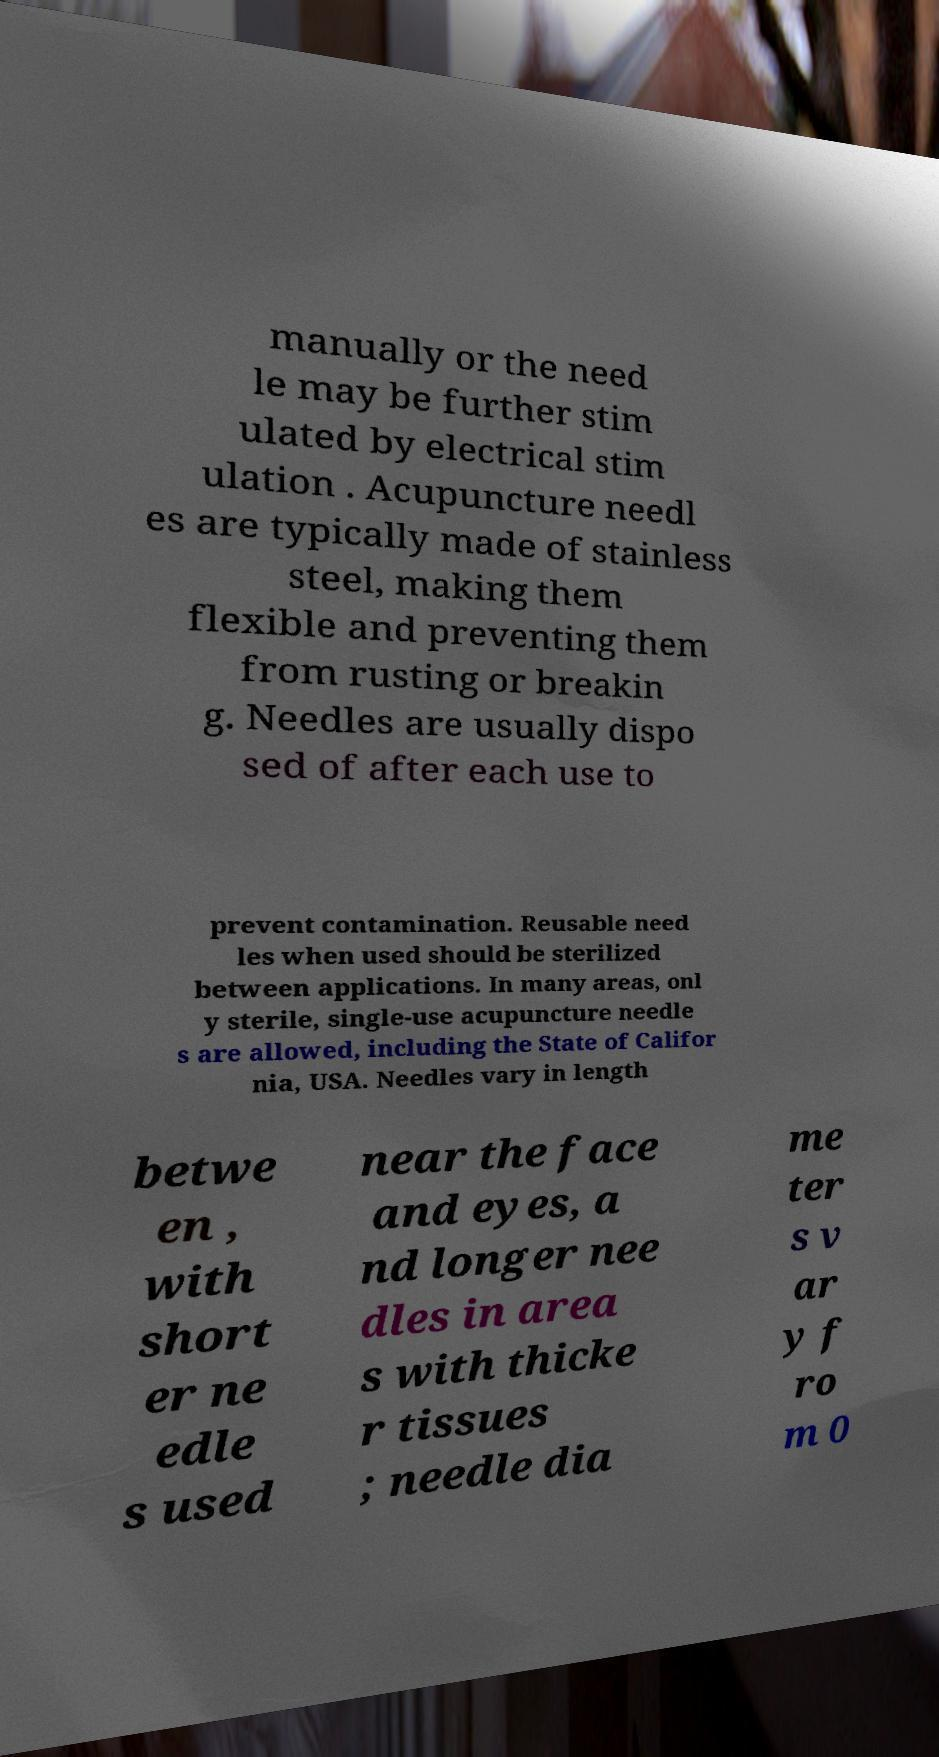I need the written content from this picture converted into text. Can you do that? manually or the need le may be further stim ulated by electrical stim ulation . Acupuncture needl es are typically made of stainless steel, making them flexible and preventing them from rusting or breakin g. Needles are usually dispo sed of after each use to prevent contamination. Reusable need les when used should be sterilized between applications. In many areas, onl y sterile, single-use acupuncture needle s are allowed, including the State of Califor nia, USA. Needles vary in length betwe en , with short er ne edle s used near the face and eyes, a nd longer nee dles in area s with thicke r tissues ; needle dia me ter s v ar y f ro m 0 